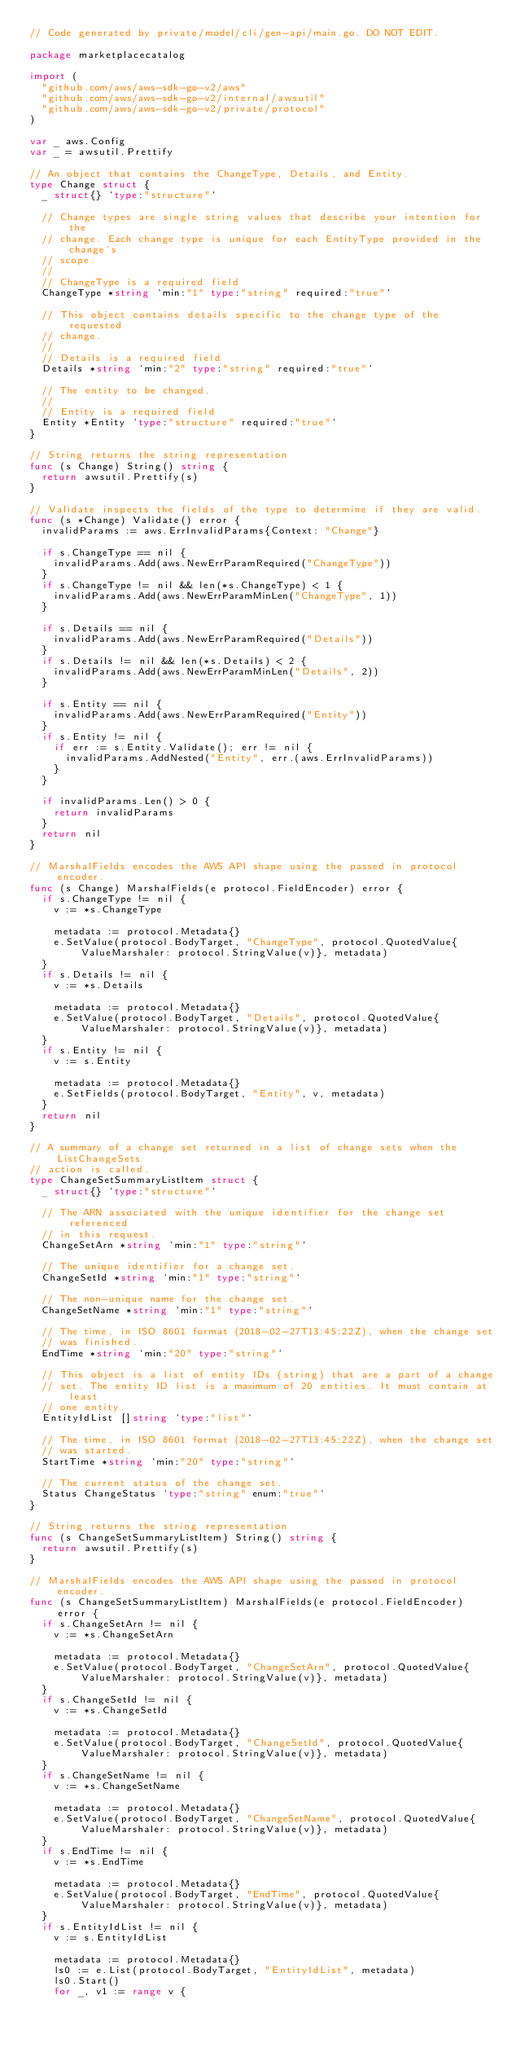<code> <loc_0><loc_0><loc_500><loc_500><_Go_>// Code generated by private/model/cli/gen-api/main.go. DO NOT EDIT.

package marketplacecatalog

import (
	"github.com/aws/aws-sdk-go-v2/aws"
	"github.com/aws/aws-sdk-go-v2/internal/awsutil"
	"github.com/aws/aws-sdk-go-v2/private/protocol"
)

var _ aws.Config
var _ = awsutil.Prettify

// An object that contains the ChangeType, Details, and Entity.
type Change struct {
	_ struct{} `type:"structure"`

	// Change types are single string values that describe your intention for the
	// change. Each change type is unique for each EntityType provided in the change's
	// scope.
	//
	// ChangeType is a required field
	ChangeType *string `min:"1" type:"string" required:"true"`

	// This object contains details specific to the change type of the requested
	// change.
	//
	// Details is a required field
	Details *string `min:"2" type:"string" required:"true"`

	// The entity to be changed.
	//
	// Entity is a required field
	Entity *Entity `type:"structure" required:"true"`
}

// String returns the string representation
func (s Change) String() string {
	return awsutil.Prettify(s)
}

// Validate inspects the fields of the type to determine if they are valid.
func (s *Change) Validate() error {
	invalidParams := aws.ErrInvalidParams{Context: "Change"}

	if s.ChangeType == nil {
		invalidParams.Add(aws.NewErrParamRequired("ChangeType"))
	}
	if s.ChangeType != nil && len(*s.ChangeType) < 1 {
		invalidParams.Add(aws.NewErrParamMinLen("ChangeType", 1))
	}

	if s.Details == nil {
		invalidParams.Add(aws.NewErrParamRequired("Details"))
	}
	if s.Details != nil && len(*s.Details) < 2 {
		invalidParams.Add(aws.NewErrParamMinLen("Details", 2))
	}

	if s.Entity == nil {
		invalidParams.Add(aws.NewErrParamRequired("Entity"))
	}
	if s.Entity != nil {
		if err := s.Entity.Validate(); err != nil {
			invalidParams.AddNested("Entity", err.(aws.ErrInvalidParams))
		}
	}

	if invalidParams.Len() > 0 {
		return invalidParams
	}
	return nil
}

// MarshalFields encodes the AWS API shape using the passed in protocol encoder.
func (s Change) MarshalFields(e protocol.FieldEncoder) error {
	if s.ChangeType != nil {
		v := *s.ChangeType

		metadata := protocol.Metadata{}
		e.SetValue(protocol.BodyTarget, "ChangeType", protocol.QuotedValue{ValueMarshaler: protocol.StringValue(v)}, metadata)
	}
	if s.Details != nil {
		v := *s.Details

		metadata := protocol.Metadata{}
		e.SetValue(protocol.BodyTarget, "Details", protocol.QuotedValue{ValueMarshaler: protocol.StringValue(v)}, metadata)
	}
	if s.Entity != nil {
		v := s.Entity

		metadata := protocol.Metadata{}
		e.SetFields(protocol.BodyTarget, "Entity", v, metadata)
	}
	return nil
}

// A summary of a change set returned in a list of change sets when the ListChangeSets
// action is called.
type ChangeSetSummaryListItem struct {
	_ struct{} `type:"structure"`

	// The ARN associated with the unique identifier for the change set referenced
	// in this request.
	ChangeSetArn *string `min:"1" type:"string"`

	// The unique identifier for a change set.
	ChangeSetId *string `min:"1" type:"string"`

	// The non-unique name for the change set.
	ChangeSetName *string `min:"1" type:"string"`

	// The time, in ISO 8601 format (2018-02-27T13:45:22Z), when the change set
	// was finished.
	EndTime *string `min:"20" type:"string"`

	// This object is a list of entity IDs (string) that are a part of a change
	// set. The entity ID list is a maximum of 20 entities. It must contain at least
	// one entity.
	EntityIdList []string `type:"list"`

	// The time, in ISO 8601 format (2018-02-27T13:45:22Z), when the change set
	// was started.
	StartTime *string `min:"20" type:"string"`

	// The current status of the change set.
	Status ChangeStatus `type:"string" enum:"true"`
}

// String returns the string representation
func (s ChangeSetSummaryListItem) String() string {
	return awsutil.Prettify(s)
}

// MarshalFields encodes the AWS API shape using the passed in protocol encoder.
func (s ChangeSetSummaryListItem) MarshalFields(e protocol.FieldEncoder) error {
	if s.ChangeSetArn != nil {
		v := *s.ChangeSetArn

		metadata := protocol.Metadata{}
		e.SetValue(protocol.BodyTarget, "ChangeSetArn", protocol.QuotedValue{ValueMarshaler: protocol.StringValue(v)}, metadata)
	}
	if s.ChangeSetId != nil {
		v := *s.ChangeSetId

		metadata := protocol.Metadata{}
		e.SetValue(protocol.BodyTarget, "ChangeSetId", protocol.QuotedValue{ValueMarshaler: protocol.StringValue(v)}, metadata)
	}
	if s.ChangeSetName != nil {
		v := *s.ChangeSetName

		metadata := protocol.Metadata{}
		e.SetValue(protocol.BodyTarget, "ChangeSetName", protocol.QuotedValue{ValueMarshaler: protocol.StringValue(v)}, metadata)
	}
	if s.EndTime != nil {
		v := *s.EndTime

		metadata := protocol.Metadata{}
		e.SetValue(protocol.BodyTarget, "EndTime", protocol.QuotedValue{ValueMarshaler: protocol.StringValue(v)}, metadata)
	}
	if s.EntityIdList != nil {
		v := s.EntityIdList

		metadata := protocol.Metadata{}
		ls0 := e.List(protocol.BodyTarget, "EntityIdList", metadata)
		ls0.Start()
		for _, v1 := range v {</code> 